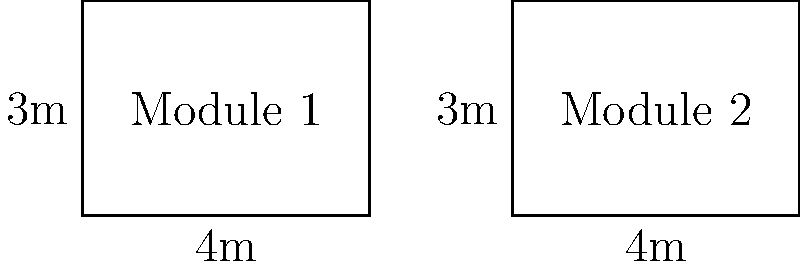In a modular building design, two rectangular modules are shown above. Given that the dimensions of Module 1 are 4m x 3m, and both modules appear identical, what is the area difference between the two modules? To solve this problem, we'll follow these steps:

1. Recognize that the two modules are congruent rectangles, meaning they have the same dimensions.

2. Calculate the area of Module 1:
   Area of Module 1 = length × width
   $A_1 = 4\text{m} \times 3\text{m} = 12\text{m}^2$

3. Since the modules are congruent, Module 2 has the same area:
   Area of Module 2 = $A_2 = 12\text{m}^2$

4. Calculate the difference in area:
   Area difference = $A_2 - A_1 = 12\text{m}^2 - 12\text{m}^2 = 0\text{m}^2$

The area difference between the two modules is 0 square meters, as they are congruent and therefore have the same area.
Answer: $0\text{m}^2$ 